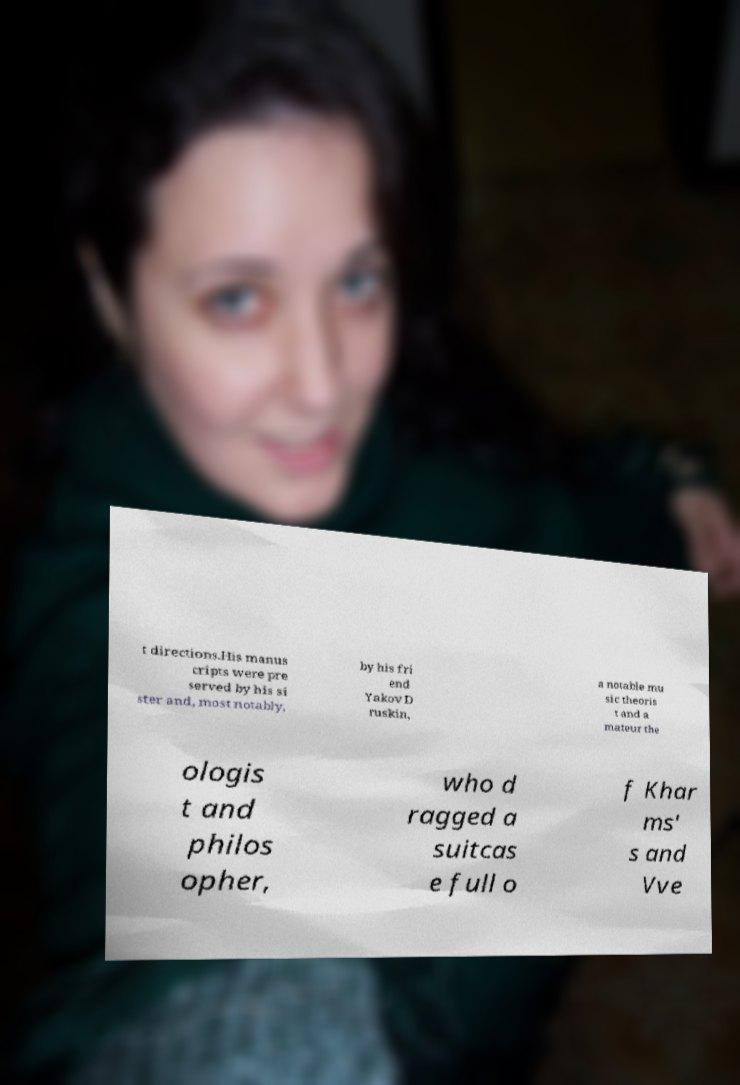Can you read and provide the text displayed in the image?This photo seems to have some interesting text. Can you extract and type it out for me? t directions.His manus cripts were pre served by his si ster and, most notably, by his fri end Yakov D ruskin, a notable mu sic theoris t and a mateur the ologis t and philos opher, who d ragged a suitcas e full o f Khar ms' s and Vve 